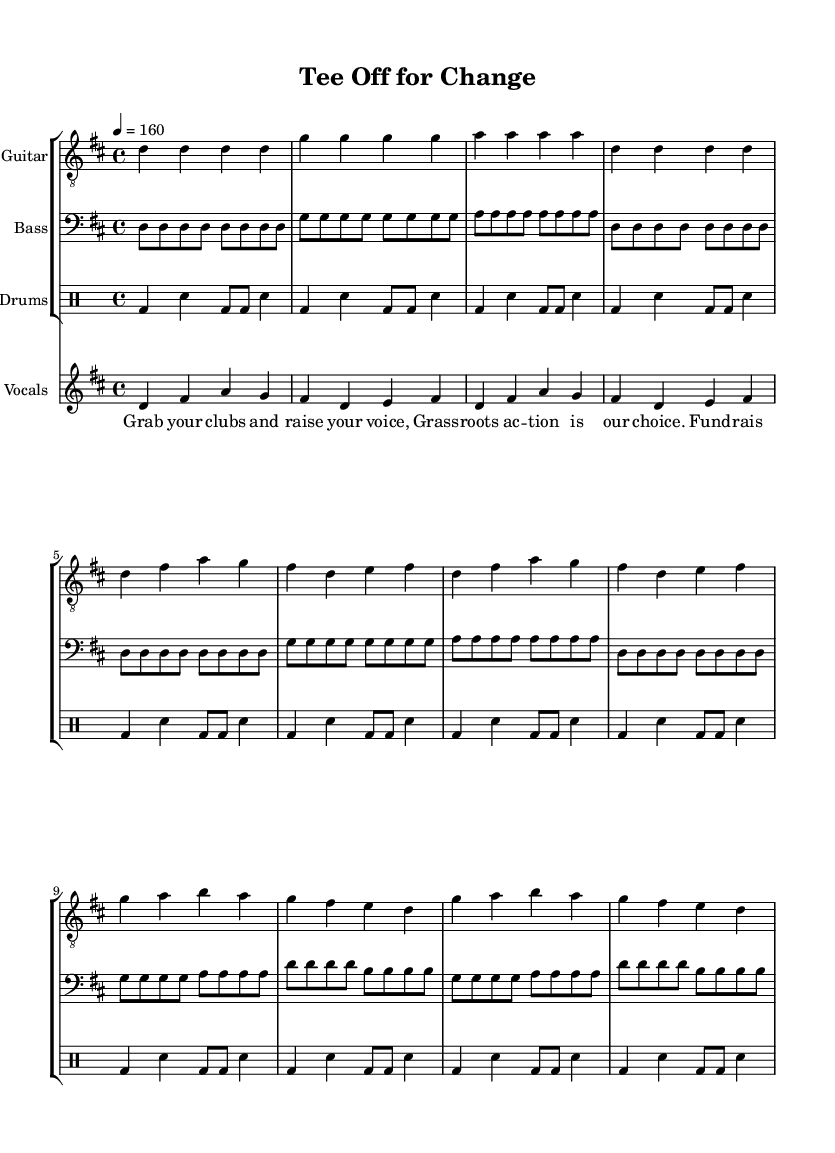What is the time signature of this music? The time signature is indicated at the beginning of the score, shown as a fraction. In this case, it is 4/4, which means there are four beats in each measure and the quarter note gets one beat.
Answer: 4/4 What is the tempo marking for this piece? The tempo is specified by the marking at the beginning of the score. Here, it is indicated as 4 = 160, meaning a quarter note should be played at a speed of 160 beats per minute.
Answer: 160 How many measures are there in the chorus? To find this, we need to count the measures specifically marked as the chorus in the sheet music. In this case, there are four measures highlighted in the chorus section.
Answer: 4 Which instrument parts are included in the score? The score includes three specific parts indicated at the start: Guitar, Bass, and Drums. These can be identified by looking at the staff names in the score layout.
Answer: Guitar, Bass, Drums What unique thematic element is present in the lyrics? The lyrics contain a direct reference to golf as a means of activism, highlighting themes of fundraising and grassroots action, which is characteristic of punk's focus on social issues.
Answer: Fundraising and grassroots action What is the key of this music? The key signature for this piece is indicated at the beginning of the score. It shows two sharps, which corresponds to D major.
Answer: D major 